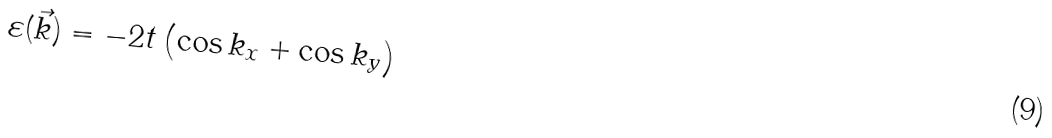<formula> <loc_0><loc_0><loc_500><loc_500>\varepsilon ( \vec { k } ) = - 2 t \left ( \cos k _ { x } + \cos k _ { y } \right )</formula> 